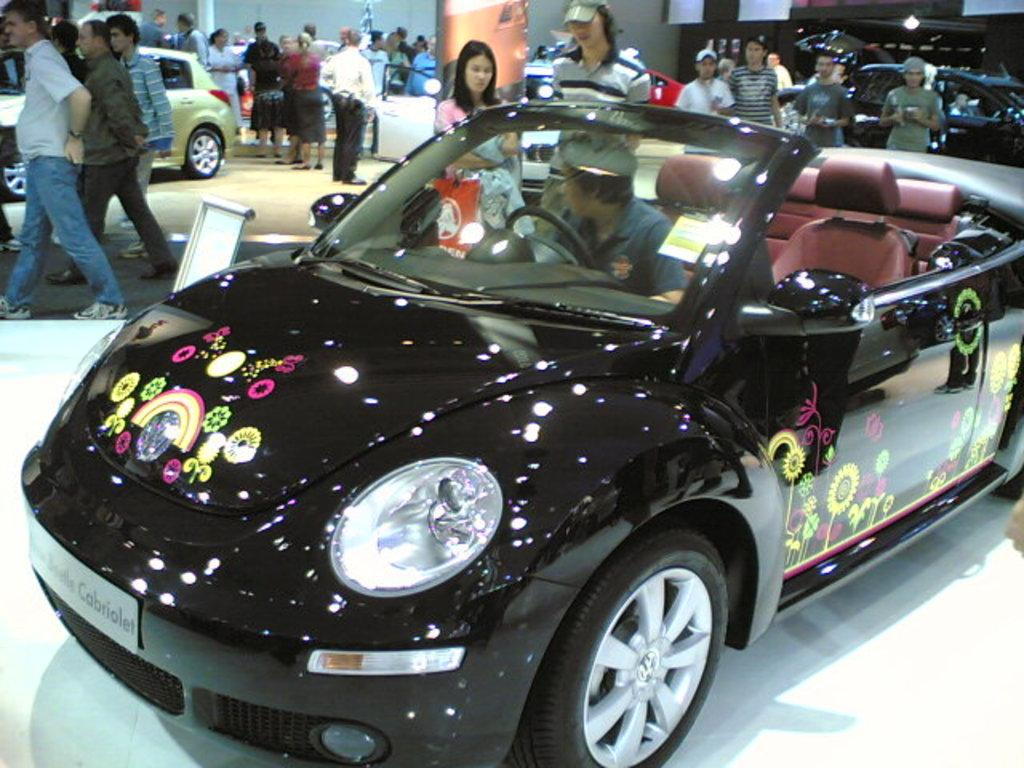What is the man in the image doing? The man is seated in a car. What can be observed about the people around the car? There are people standing around the car. What type of lumber is being used to construct the place in the image? There is no mention of lumber or a place being constructed in the image. 